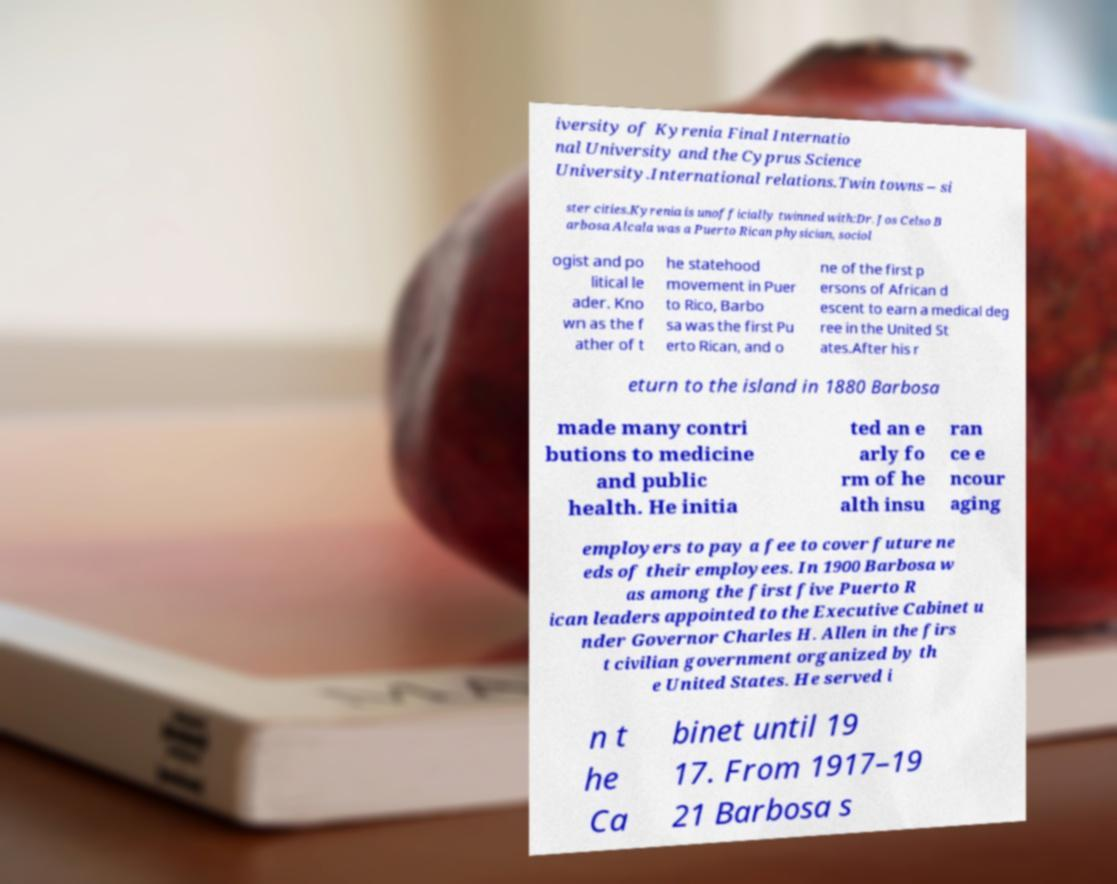I need the written content from this picture converted into text. Can you do that? iversity of Kyrenia Final Internatio nal University and the Cyprus Science University.International relations.Twin towns – si ster cities.Kyrenia is unofficially twinned with:Dr. Jos Celso B arbosa Alcala was a Puerto Rican physician, sociol ogist and po litical le ader. Kno wn as the f ather of t he statehood movement in Puer to Rico, Barbo sa was the first Pu erto Rican, and o ne of the first p ersons of African d escent to earn a medical deg ree in the United St ates.After his r eturn to the island in 1880 Barbosa made many contri butions to medicine and public health. He initia ted an e arly fo rm of he alth insu ran ce e ncour aging employers to pay a fee to cover future ne eds of their employees. In 1900 Barbosa w as among the first five Puerto R ican leaders appointed to the Executive Cabinet u nder Governor Charles H. Allen in the firs t civilian government organized by th e United States. He served i n t he Ca binet until 19 17. From 1917–19 21 Barbosa s 